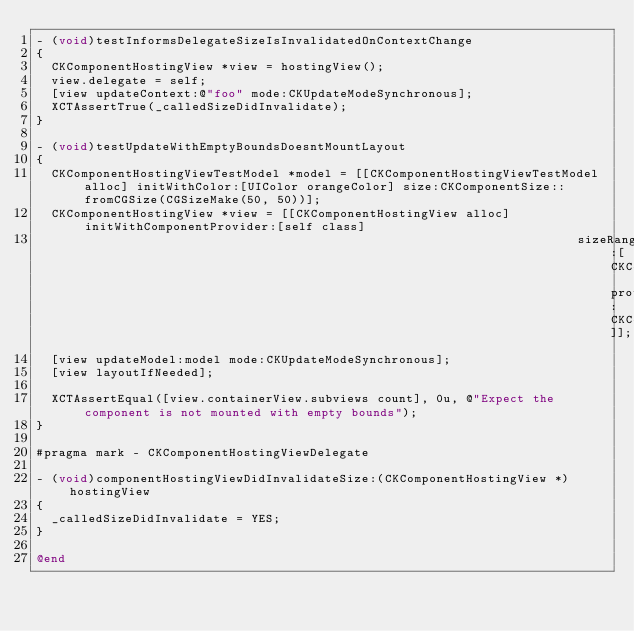Convert code to text. <code><loc_0><loc_0><loc_500><loc_500><_ObjectiveC_>- (void)testInformsDelegateSizeIsInvalidatedOnContextChange
{
  CKComponentHostingView *view = hostingView();
  view.delegate = self;
  [view updateContext:@"foo" mode:CKUpdateModeSynchronous];
  XCTAssertTrue(_calledSizeDidInvalidate);
}

- (void)testUpdateWithEmptyBoundsDoesntMountLayout
{
  CKComponentHostingViewTestModel *model = [[CKComponentHostingViewTestModel alloc] initWithColor:[UIColor orangeColor] size:CKComponentSize::fromCGSize(CGSizeMake(50, 50))];
  CKComponentHostingView *view = [[CKComponentHostingView alloc] initWithComponentProvider:[self class]
                                                                         sizeRangeProvider:[CKComponentFlexibleSizeRangeProvider providerWithFlexibility:CKComponentSizeRangeFlexibleWidthAndHeight]];
  [view updateModel:model mode:CKUpdateModeSynchronous];
  [view layoutIfNeeded];

  XCTAssertEqual([view.containerView.subviews count], 0u, @"Expect the component is not mounted with empty bounds");
}

#pragma mark - CKComponentHostingViewDelegate

- (void)componentHostingViewDidInvalidateSize:(CKComponentHostingView *)hostingView
{
  _calledSizeDidInvalidate = YES;
}

@end
</code> 